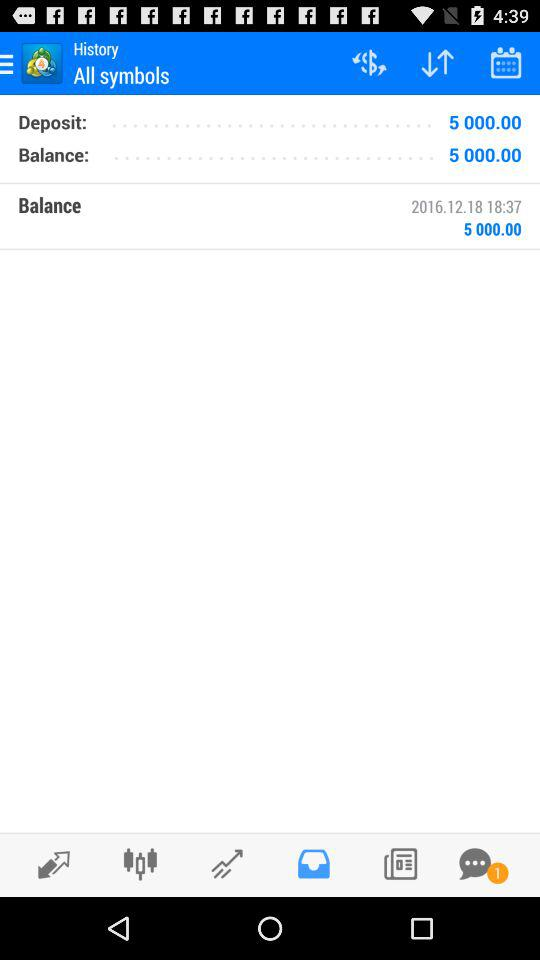What is the total balance for December 18, 2016? The balance is $5,000. 